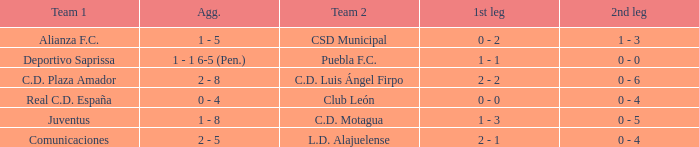What is the 2nd leg of the Comunicaciones team? 0 - 4. 